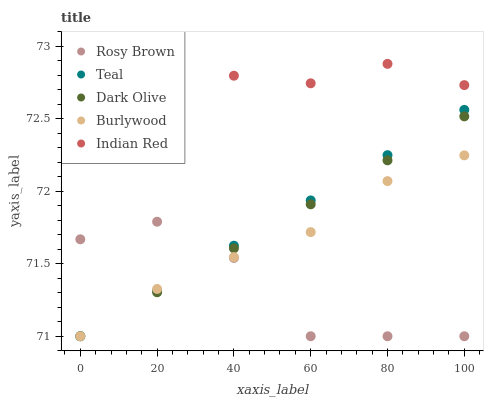Does Rosy Brown have the minimum area under the curve?
Answer yes or no. Yes. Does Indian Red have the maximum area under the curve?
Answer yes or no. Yes. Does Burlywood have the minimum area under the curve?
Answer yes or no. No. Does Burlywood have the maximum area under the curve?
Answer yes or no. No. Is Dark Olive the smoothest?
Answer yes or no. Yes. Is Rosy Brown the roughest?
Answer yes or no. Yes. Is Burlywood the smoothest?
Answer yes or no. No. Is Burlywood the roughest?
Answer yes or no. No. Does Dark Olive have the lowest value?
Answer yes or no. Yes. Does Indian Red have the lowest value?
Answer yes or no. No. Does Indian Red have the highest value?
Answer yes or no. Yes. Does Burlywood have the highest value?
Answer yes or no. No. Is Dark Olive less than Indian Red?
Answer yes or no. Yes. Is Indian Red greater than Burlywood?
Answer yes or no. Yes. Does Teal intersect Rosy Brown?
Answer yes or no. Yes. Is Teal less than Rosy Brown?
Answer yes or no. No. Is Teal greater than Rosy Brown?
Answer yes or no. No. Does Dark Olive intersect Indian Red?
Answer yes or no. No. 